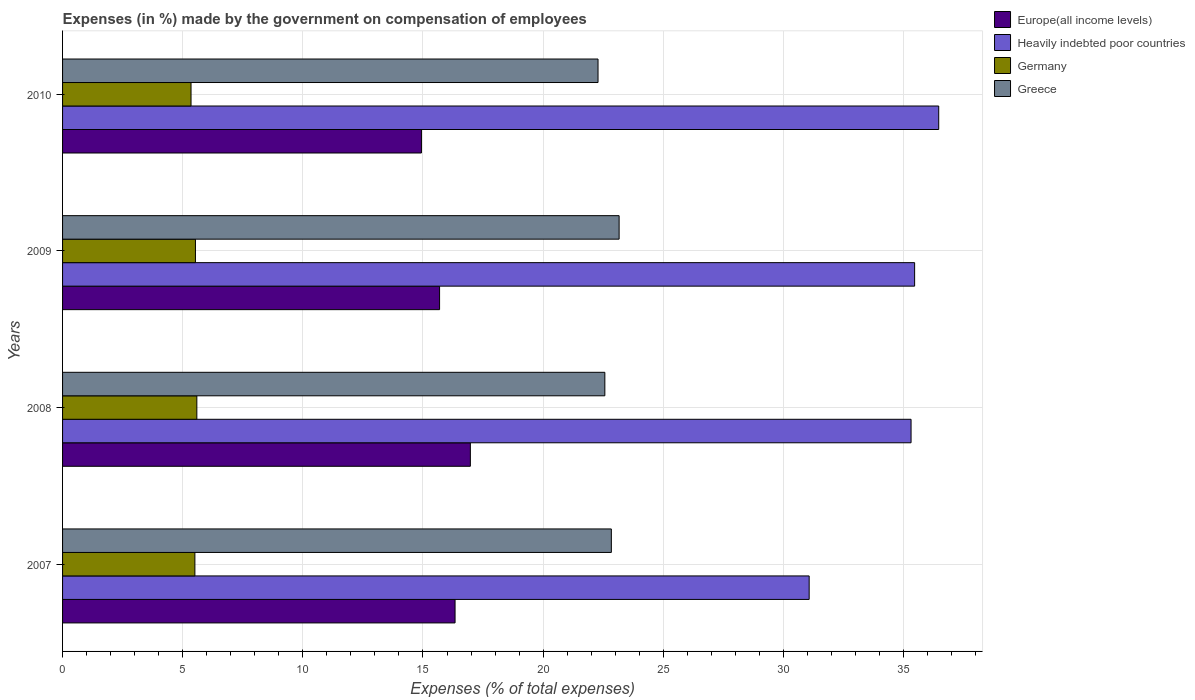How many groups of bars are there?
Your answer should be very brief. 4. Are the number of bars per tick equal to the number of legend labels?
Keep it short and to the point. Yes. How many bars are there on the 4th tick from the top?
Give a very brief answer. 4. What is the label of the 2nd group of bars from the top?
Your response must be concise. 2009. What is the percentage of expenses made by the government on compensation of employees in Heavily indebted poor countries in 2010?
Offer a terse response. 36.46. Across all years, what is the maximum percentage of expenses made by the government on compensation of employees in Germany?
Provide a succinct answer. 5.59. Across all years, what is the minimum percentage of expenses made by the government on compensation of employees in Europe(all income levels)?
Ensure brevity in your answer.  14.94. In which year was the percentage of expenses made by the government on compensation of employees in Greece maximum?
Provide a short and direct response. 2009. What is the total percentage of expenses made by the government on compensation of employees in Greece in the graph?
Provide a succinct answer. 90.86. What is the difference between the percentage of expenses made by the government on compensation of employees in Heavily indebted poor countries in 2007 and that in 2009?
Offer a very short reply. -4.39. What is the difference between the percentage of expenses made by the government on compensation of employees in Greece in 2010 and the percentage of expenses made by the government on compensation of employees in Heavily indebted poor countries in 2008?
Offer a very short reply. -13.03. What is the average percentage of expenses made by the government on compensation of employees in Europe(all income levels) per year?
Make the answer very short. 15.98. In the year 2007, what is the difference between the percentage of expenses made by the government on compensation of employees in Europe(all income levels) and percentage of expenses made by the government on compensation of employees in Germany?
Offer a very short reply. 10.83. In how many years, is the percentage of expenses made by the government on compensation of employees in Germany greater than 14 %?
Keep it short and to the point. 0. What is the ratio of the percentage of expenses made by the government on compensation of employees in Greece in 2009 to that in 2010?
Ensure brevity in your answer.  1.04. What is the difference between the highest and the second highest percentage of expenses made by the government on compensation of employees in Germany?
Provide a succinct answer. 0.06. What is the difference between the highest and the lowest percentage of expenses made by the government on compensation of employees in Europe(all income levels)?
Give a very brief answer. 2.04. In how many years, is the percentage of expenses made by the government on compensation of employees in Greece greater than the average percentage of expenses made by the government on compensation of employees in Greece taken over all years?
Give a very brief answer. 2. Is the sum of the percentage of expenses made by the government on compensation of employees in Europe(all income levels) in 2008 and 2010 greater than the maximum percentage of expenses made by the government on compensation of employees in Germany across all years?
Keep it short and to the point. Yes. Is it the case that in every year, the sum of the percentage of expenses made by the government on compensation of employees in Greece and percentage of expenses made by the government on compensation of employees in Europe(all income levels) is greater than the sum of percentage of expenses made by the government on compensation of employees in Germany and percentage of expenses made by the government on compensation of employees in Heavily indebted poor countries?
Provide a succinct answer. Yes. What does the 1st bar from the bottom in 2009 represents?
Your response must be concise. Europe(all income levels). Is it the case that in every year, the sum of the percentage of expenses made by the government on compensation of employees in Germany and percentage of expenses made by the government on compensation of employees in Greece is greater than the percentage of expenses made by the government on compensation of employees in Europe(all income levels)?
Your answer should be compact. Yes. Are all the bars in the graph horizontal?
Offer a terse response. Yes. Does the graph contain grids?
Make the answer very short. Yes. How many legend labels are there?
Ensure brevity in your answer.  4. How are the legend labels stacked?
Your answer should be very brief. Vertical. What is the title of the graph?
Offer a very short reply. Expenses (in %) made by the government on compensation of employees. What is the label or title of the X-axis?
Offer a terse response. Expenses (% of total expenses). What is the label or title of the Y-axis?
Offer a very short reply. Years. What is the Expenses (% of total expenses) in Europe(all income levels) in 2007?
Keep it short and to the point. 16.34. What is the Expenses (% of total expenses) in Heavily indebted poor countries in 2007?
Make the answer very short. 31.07. What is the Expenses (% of total expenses) in Germany in 2007?
Keep it short and to the point. 5.51. What is the Expenses (% of total expenses) of Greece in 2007?
Your answer should be compact. 22.84. What is the Expenses (% of total expenses) in Europe(all income levels) in 2008?
Your answer should be compact. 16.97. What is the Expenses (% of total expenses) in Heavily indebted poor countries in 2008?
Give a very brief answer. 35.31. What is the Expenses (% of total expenses) of Germany in 2008?
Offer a very short reply. 5.59. What is the Expenses (% of total expenses) of Greece in 2008?
Make the answer very short. 22.57. What is the Expenses (% of total expenses) of Europe(all income levels) in 2009?
Make the answer very short. 15.69. What is the Expenses (% of total expenses) of Heavily indebted poor countries in 2009?
Provide a succinct answer. 35.46. What is the Expenses (% of total expenses) in Germany in 2009?
Make the answer very short. 5.53. What is the Expenses (% of total expenses) in Greece in 2009?
Your response must be concise. 23.16. What is the Expenses (% of total expenses) in Europe(all income levels) in 2010?
Make the answer very short. 14.94. What is the Expenses (% of total expenses) in Heavily indebted poor countries in 2010?
Provide a succinct answer. 36.46. What is the Expenses (% of total expenses) in Germany in 2010?
Provide a short and direct response. 5.35. What is the Expenses (% of total expenses) of Greece in 2010?
Your answer should be compact. 22.29. Across all years, what is the maximum Expenses (% of total expenses) in Europe(all income levels)?
Offer a very short reply. 16.97. Across all years, what is the maximum Expenses (% of total expenses) in Heavily indebted poor countries?
Offer a terse response. 36.46. Across all years, what is the maximum Expenses (% of total expenses) in Germany?
Your answer should be very brief. 5.59. Across all years, what is the maximum Expenses (% of total expenses) in Greece?
Offer a very short reply. 23.16. Across all years, what is the minimum Expenses (% of total expenses) of Europe(all income levels)?
Your response must be concise. 14.94. Across all years, what is the minimum Expenses (% of total expenses) in Heavily indebted poor countries?
Your answer should be very brief. 31.07. Across all years, what is the minimum Expenses (% of total expenses) in Germany?
Ensure brevity in your answer.  5.35. Across all years, what is the minimum Expenses (% of total expenses) of Greece?
Your answer should be compact. 22.29. What is the total Expenses (% of total expenses) in Europe(all income levels) in the graph?
Your answer should be compact. 63.93. What is the total Expenses (% of total expenses) of Heavily indebted poor countries in the graph?
Provide a short and direct response. 138.31. What is the total Expenses (% of total expenses) of Germany in the graph?
Your answer should be very brief. 21.97. What is the total Expenses (% of total expenses) in Greece in the graph?
Keep it short and to the point. 90.86. What is the difference between the Expenses (% of total expenses) in Europe(all income levels) in 2007 and that in 2008?
Give a very brief answer. -0.64. What is the difference between the Expenses (% of total expenses) of Heavily indebted poor countries in 2007 and that in 2008?
Provide a succinct answer. -4.24. What is the difference between the Expenses (% of total expenses) in Germany in 2007 and that in 2008?
Make the answer very short. -0.08. What is the difference between the Expenses (% of total expenses) in Greece in 2007 and that in 2008?
Your answer should be compact. 0.27. What is the difference between the Expenses (% of total expenses) in Europe(all income levels) in 2007 and that in 2009?
Keep it short and to the point. 0.64. What is the difference between the Expenses (% of total expenses) of Heavily indebted poor countries in 2007 and that in 2009?
Keep it short and to the point. -4.39. What is the difference between the Expenses (% of total expenses) in Germany in 2007 and that in 2009?
Keep it short and to the point. -0.02. What is the difference between the Expenses (% of total expenses) of Greece in 2007 and that in 2009?
Your answer should be very brief. -0.32. What is the difference between the Expenses (% of total expenses) in Europe(all income levels) in 2007 and that in 2010?
Provide a short and direct response. 1.4. What is the difference between the Expenses (% of total expenses) in Heavily indebted poor countries in 2007 and that in 2010?
Provide a short and direct response. -5.39. What is the difference between the Expenses (% of total expenses) of Germany in 2007 and that in 2010?
Your response must be concise. 0.16. What is the difference between the Expenses (% of total expenses) in Greece in 2007 and that in 2010?
Give a very brief answer. 0.55. What is the difference between the Expenses (% of total expenses) in Europe(all income levels) in 2008 and that in 2009?
Provide a succinct answer. 1.28. What is the difference between the Expenses (% of total expenses) of Heavily indebted poor countries in 2008 and that in 2009?
Provide a short and direct response. -0.15. What is the difference between the Expenses (% of total expenses) in Germany in 2008 and that in 2009?
Keep it short and to the point. 0.06. What is the difference between the Expenses (% of total expenses) in Greece in 2008 and that in 2009?
Your answer should be very brief. -0.59. What is the difference between the Expenses (% of total expenses) in Europe(all income levels) in 2008 and that in 2010?
Ensure brevity in your answer.  2.04. What is the difference between the Expenses (% of total expenses) of Heavily indebted poor countries in 2008 and that in 2010?
Ensure brevity in your answer.  -1.15. What is the difference between the Expenses (% of total expenses) in Germany in 2008 and that in 2010?
Provide a short and direct response. 0.24. What is the difference between the Expenses (% of total expenses) in Greece in 2008 and that in 2010?
Your answer should be compact. 0.28. What is the difference between the Expenses (% of total expenses) in Europe(all income levels) in 2009 and that in 2010?
Offer a terse response. 0.75. What is the difference between the Expenses (% of total expenses) of Heavily indebted poor countries in 2009 and that in 2010?
Your answer should be very brief. -1. What is the difference between the Expenses (% of total expenses) in Germany in 2009 and that in 2010?
Offer a very short reply. 0.18. What is the difference between the Expenses (% of total expenses) of Greece in 2009 and that in 2010?
Your response must be concise. 0.88. What is the difference between the Expenses (% of total expenses) in Europe(all income levels) in 2007 and the Expenses (% of total expenses) in Heavily indebted poor countries in 2008?
Offer a very short reply. -18.98. What is the difference between the Expenses (% of total expenses) of Europe(all income levels) in 2007 and the Expenses (% of total expenses) of Germany in 2008?
Your answer should be very brief. 10.75. What is the difference between the Expenses (% of total expenses) of Europe(all income levels) in 2007 and the Expenses (% of total expenses) of Greece in 2008?
Provide a succinct answer. -6.23. What is the difference between the Expenses (% of total expenses) in Heavily indebted poor countries in 2007 and the Expenses (% of total expenses) in Germany in 2008?
Ensure brevity in your answer.  25.48. What is the difference between the Expenses (% of total expenses) of Heavily indebted poor countries in 2007 and the Expenses (% of total expenses) of Greece in 2008?
Make the answer very short. 8.5. What is the difference between the Expenses (% of total expenses) in Germany in 2007 and the Expenses (% of total expenses) in Greece in 2008?
Offer a terse response. -17.06. What is the difference between the Expenses (% of total expenses) of Europe(all income levels) in 2007 and the Expenses (% of total expenses) of Heavily indebted poor countries in 2009?
Ensure brevity in your answer.  -19.13. What is the difference between the Expenses (% of total expenses) in Europe(all income levels) in 2007 and the Expenses (% of total expenses) in Germany in 2009?
Your response must be concise. 10.8. What is the difference between the Expenses (% of total expenses) in Europe(all income levels) in 2007 and the Expenses (% of total expenses) in Greece in 2009?
Offer a very short reply. -6.83. What is the difference between the Expenses (% of total expenses) of Heavily indebted poor countries in 2007 and the Expenses (% of total expenses) of Germany in 2009?
Give a very brief answer. 25.54. What is the difference between the Expenses (% of total expenses) of Heavily indebted poor countries in 2007 and the Expenses (% of total expenses) of Greece in 2009?
Ensure brevity in your answer.  7.91. What is the difference between the Expenses (% of total expenses) in Germany in 2007 and the Expenses (% of total expenses) in Greece in 2009?
Offer a very short reply. -17.66. What is the difference between the Expenses (% of total expenses) in Europe(all income levels) in 2007 and the Expenses (% of total expenses) in Heavily indebted poor countries in 2010?
Provide a succinct answer. -20.13. What is the difference between the Expenses (% of total expenses) of Europe(all income levels) in 2007 and the Expenses (% of total expenses) of Germany in 2010?
Your answer should be compact. 10.99. What is the difference between the Expenses (% of total expenses) in Europe(all income levels) in 2007 and the Expenses (% of total expenses) in Greece in 2010?
Your answer should be very brief. -5.95. What is the difference between the Expenses (% of total expenses) in Heavily indebted poor countries in 2007 and the Expenses (% of total expenses) in Germany in 2010?
Offer a very short reply. 25.73. What is the difference between the Expenses (% of total expenses) of Heavily indebted poor countries in 2007 and the Expenses (% of total expenses) of Greece in 2010?
Keep it short and to the point. 8.79. What is the difference between the Expenses (% of total expenses) of Germany in 2007 and the Expenses (% of total expenses) of Greece in 2010?
Make the answer very short. -16.78. What is the difference between the Expenses (% of total expenses) of Europe(all income levels) in 2008 and the Expenses (% of total expenses) of Heavily indebted poor countries in 2009?
Your response must be concise. -18.49. What is the difference between the Expenses (% of total expenses) of Europe(all income levels) in 2008 and the Expenses (% of total expenses) of Germany in 2009?
Offer a very short reply. 11.44. What is the difference between the Expenses (% of total expenses) in Europe(all income levels) in 2008 and the Expenses (% of total expenses) in Greece in 2009?
Your answer should be very brief. -6.19. What is the difference between the Expenses (% of total expenses) in Heavily indebted poor countries in 2008 and the Expenses (% of total expenses) in Germany in 2009?
Offer a very short reply. 29.78. What is the difference between the Expenses (% of total expenses) of Heavily indebted poor countries in 2008 and the Expenses (% of total expenses) of Greece in 2009?
Ensure brevity in your answer.  12.15. What is the difference between the Expenses (% of total expenses) of Germany in 2008 and the Expenses (% of total expenses) of Greece in 2009?
Offer a very short reply. -17.57. What is the difference between the Expenses (% of total expenses) of Europe(all income levels) in 2008 and the Expenses (% of total expenses) of Heavily indebted poor countries in 2010?
Offer a terse response. -19.49. What is the difference between the Expenses (% of total expenses) in Europe(all income levels) in 2008 and the Expenses (% of total expenses) in Germany in 2010?
Make the answer very short. 11.62. What is the difference between the Expenses (% of total expenses) in Europe(all income levels) in 2008 and the Expenses (% of total expenses) in Greece in 2010?
Provide a short and direct response. -5.31. What is the difference between the Expenses (% of total expenses) in Heavily indebted poor countries in 2008 and the Expenses (% of total expenses) in Germany in 2010?
Make the answer very short. 29.97. What is the difference between the Expenses (% of total expenses) in Heavily indebted poor countries in 2008 and the Expenses (% of total expenses) in Greece in 2010?
Ensure brevity in your answer.  13.03. What is the difference between the Expenses (% of total expenses) of Germany in 2008 and the Expenses (% of total expenses) of Greece in 2010?
Your response must be concise. -16.7. What is the difference between the Expenses (% of total expenses) in Europe(all income levels) in 2009 and the Expenses (% of total expenses) in Heavily indebted poor countries in 2010?
Ensure brevity in your answer.  -20.77. What is the difference between the Expenses (% of total expenses) in Europe(all income levels) in 2009 and the Expenses (% of total expenses) in Germany in 2010?
Your response must be concise. 10.34. What is the difference between the Expenses (% of total expenses) of Europe(all income levels) in 2009 and the Expenses (% of total expenses) of Greece in 2010?
Make the answer very short. -6.59. What is the difference between the Expenses (% of total expenses) in Heavily indebted poor countries in 2009 and the Expenses (% of total expenses) in Germany in 2010?
Ensure brevity in your answer.  30.12. What is the difference between the Expenses (% of total expenses) of Heavily indebted poor countries in 2009 and the Expenses (% of total expenses) of Greece in 2010?
Provide a succinct answer. 13.18. What is the difference between the Expenses (% of total expenses) of Germany in 2009 and the Expenses (% of total expenses) of Greece in 2010?
Your response must be concise. -16.75. What is the average Expenses (% of total expenses) of Europe(all income levels) per year?
Give a very brief answer. 15.98. What is the average Expenses (% of total expenses) of Heavily indebted poor countries per year?
Ensure brevity in your answer.  34.58. What is the average Expenses (% of total expenses) in Germany per year?
Provide a succinct answer. 5.49. What is the average Expenses (% of total expenses) in Greece per year?
Offer a terse response. 22.71. In the year 2007, what is the difference between the Expenses (% of total expenses) in Europe(all income levels) and Expenses (% of total expenses) in Heavily indebted poor countries?
Your response must be concise. -14.74. In the year 2007, what is the difference between the Expenses (% of total expenses) of Europe(all income levels) and Expenses (% of total expenses) of Germany?
Provide a short and direct response. 10.83. In the year 2007, what is the difference between the Expenses (% of total expenses) of Europe(all income levels) and Expenses (% of total expenses) of Greece?
Make the answer very short. -6.5. In the year 2007, what is the difference between the Expenses (% of total expenses) in Heavily indebted poor countries and Expenses (% of total expenses) in Germany?
Ensure brevity in your answer.  25.57. In the year 2007, what is the difference between the Expenses (% of total expenses) in Heavily indebted poor countries and Expenses (% of total expenses) in Greece?
Your response must be concise. 8.23. In the year 2007, what is the difference between the Expenses (% of total expenses) of Germany and Expenses (% of total expenses) of Greece?
Provide a short and direct response. -17.33. In the year 2008, what is the difference between the Expenses (% of total expenses) of Europe(all income levels) and Expenses (% of total expenses) of Heavily indebted poor countries?
Provide a short and direct response. -18.34. In the year 2008, what is the difference between the Expenses (% of total expenses) in Europe(all income levels) and Expenses (% of total expenses) in Germany?
Keep it short and to the point. 11.38. In the year 2008, what is the difference between the Expenses (% of total expenses) of Europe(all income levels) and Expenses (% of total expenses) of Greece?
Your answer should be very brief. -5.6. In the year 2008, what is the difference between the Expenses (% of total expenses) of Heavily indebted poor countries and Expenses (% of total expenses) of Germany?
Provide a short and direct response. 29.73. In the year 2008, what is the difference between the Expenses (% of total expenses) of Heavily indebted poor countries and Expenses (% of total expenses) of Greece?
Your answer should be very brief. 12.74. In the year 2008, what is the difference between the Expenses (% of total expenses) of Germany and Expenses (% of total expenses) of Greece?
Provide a succinct answer. -16.98. In the year 2009, what is the difference between the Expenses (% of total expenses) of Europe(all income levels) and Expenses (% of total expenses) of Heavily indebted poor countries?
Keep it short and to the point. -19.77. In the year 2009, what is the difference between the Expenses (% of total expenses) in Europe(all income levels) and Expenses (% of total expenses) in Germany?
Provide a succinct answer. 10.16. In the year 2009, what is the difference between the Expenses (% of total expenses) in Europe(all income levels) and Expenses (% of total expenses) in Greece?
Give a very brief answer. -7.47. In the year 2009, what is the difference between the Expenses (% of total expenses) of Heavily indebted poor countries and Expenses (% of total expenses) of Germany?
Your response must be concise. 29.93. In the year 2009, what is the difference between the Expenses (% of total expenses) of Heavily indebted poor countries and Expenses (% of total expenses) of Greece?
Provide a succinct answer. 12.3. In the year 2009, what is the difference between the Expenses (% of total expenses) in Germany and Expenses (% of total expenses) in Greece?
Ensure brevity in your answer.  -17.63. In the year 2010, what is the difference between the Expenses (% of total expenses) in Europe(all income levels) and Expenses (% of total expenses) in Heavily indebted poor countries?
Make the answer very short. -21.53. In the year 2010, what is the difference between the Expenses (% of total expenses) in Europe(all income levels) and Expenses (% of total expenses) in Germany?
Provide a short and direct response. 9.59. In the year 2010, what is the difference between the Expenses (% of total expenses) in Europe(all income levels) and Expenses (% of total expenses) in Greece?
Offer a terse response. -7.35. In the year 2010, what is the difference between the Expenses (% of total expenses) in Heavily indebted poor countries and Expenses (% of total expenses) in Germany?
Ensure brevity in your answer.  31.12. In the year 2010, what is the difference between the Expenses (% of total expenses) of Heavily indebted poor countries and Expenses (% of total expenses) of Greece?
Offer a very short reply. 14.18. In the year 2010, what is the difference between the Expenses (% of total expenses) of Germany and Expenses (% of total expenses) of Greece?
Give a very brief answer. -16.94. What is the ratio of the Expenses (% of total expenses) of Europe(all income levels) in 2007 to that in 2008?
Ensure brevity in your answer.  0.96. What is the ratio of the Expenses (% of total expenses) in Heavily indebted poor countries in 2007 to that in 2008?
Make the answer very short. 0.88. What is the ratio of the Expenses (% of total expenses) of Germany in 2007 to that in 2008?
Keep it short and to the point. 0.99. What is the ratio of the Expenses (% of total expenses) in Europe(all income levels) in 2007 to that in 2009?
Ensure brevity in your answer.  1.04. What is the ratio of the Expenses (% of total expenses) of Heavily indebted poor countries in 2007 to that in 2009?
Your response must be concise. 0.88. What is the ratio of the Expenses (% of total expenses) in Germany in 2007 to that in 2009?
Provide a short and direct response. 1. What is the ratio of the Expenses (% of total expenses) in Greece in 2007 to that in 2009?
Your answer should be compact. 0.99. What is the ratio of the Expenses (% of total expenses) in Europe(all income levels) in 2007 to that in 2010?
Offer a very short reply. 1.09. What is the ratio of the Expenses (% of total expenses) of Heavily indebted poor countries in 2007 to that in 2010?
Offer a terse response. 0.85. What is the ratio of the Expenses (% of total expenses) in Germany in 2007 to that in 2010?
Your response must be concise. 1.03. What is the ratio of the Expenses (% of total expenses) in Greece in 2007 to that in 2010?
Keep it short and to the point. 1.02. What is the ratio of the Expenses (% of total expenses) of Europe(all income levels) in 2008 to that in 2009?
Ensure brevity in your answer.  1.08. What is the ratio of the Expenses (% of total expenses) in Germany in 2008 to that in 2009?
Offer a terse response. 1.01. What is the ratio of the Expenses (% of total expenses) in Greece in 2008 to that in 2009?
Ensure brevity in your answer.  0.97. What is the ratio of the Expenses (% of total expenses) of Europe(all income levels) in 2008 to that in 2010?
Your answer should be very brief. 1.14. What is the ratio of the Expenses (% of total expenses) in Heavily indebted poor countries in 2008 to that in 2010?
Your answer should be compact. 0.97. What is the ratio of the Expenses (% of total expenses) of Germany in 2008 to that in 2010?
Your response must be concise. 1.05. What is the ratio of the Expenses (% of total expenses) of Greece in 2008 to that in 2010?
Your response must be concise. 1.01. What is the ratio of the Expenses (% of total expenses) of Europe(all income levels) in 2009 to that in 2010?
Provide a succinct answer. 1.05. What is the ratio of the Expenses (% of total expenses) in Heavily indebted poor countries in 2009 to that in 2010?
Your answer should be compact. 0.97. What is the ratio of the Expenses (% of total expenses) of Germany in 2009 to that in 2010?
Your response must be concise. 1.03. What is the ratio of the Expenses (% of total expenses) in Greece in 2009 to that in 2010?
Provide a succinct answer. 1.04. What is the difference between the highest and the second highest Expenses (% of total expenses) in Europe(all income levels)?
Provide a short and direct response. 0.64. What is the difference between the highest and the second highest Expenses (% of total expenses) of Germany?
Make the answer very short. 0.06. What is the difference between the highest and the second highest Expenses (% of total expenses) in Greece?
Offer a terse response. 0.32. What is the difference between the highest and the lowest Expenses (% of total expenses) in Europe(all income levels)?
Provide a succinct answer. 2.04. What is the difference between the highest and the lowest Expenses (% of total expenses) in Heavily indebted poor countries?
Your answer should be compact. 5.39. What is the difference between the highest and the lowest Expenses (% of total expenses) of Germany?
Give a very brief answer. 0.24. What is the difference between the highest and the lowest Expenses (% of total expenses) of Greece?
Keep it short and to the point. 0.88. 